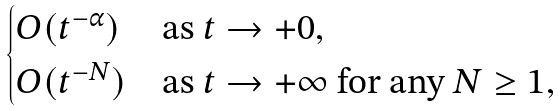Convert formula to latex. <formula><loc_0><loc_0><loc_500><loc_500>\begin{cases} O ( t ^ { - \alpha } ) & \text {as $t \to +0$} , \\ O ( t ^ { - N } ) & \text {as $t \to +\infty$ for any $N \geq 1$} , \end{cases}</formula> 